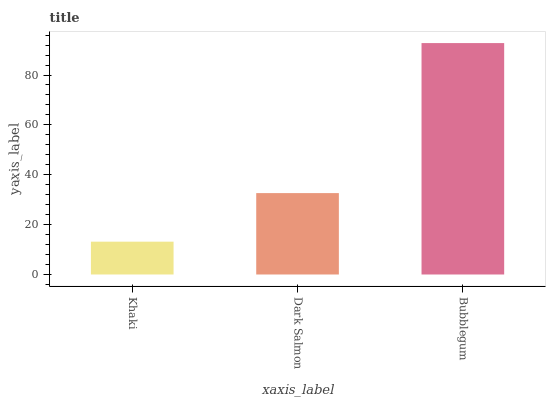Is Khaki the minimum?
Answer yes or no. Yes. Is Bubblegum the maximum?
Answer yes or no. Yes. Is Dark Salmon the minimum?
Answer yes or no. No. Is Dark Salmon the maximum?
Answer yes or no. No. Is Dark Salmon greater than Khaki?
Answer yes or no. Yes. Is Khaki less than Dark Salmon?
Answer yes or no. Yes. Is Khaki greater than Dark Salmon?
Answer yes or no. No. Is Dark Salmon less than Khaki?
Answer yes or no. No. Is Dark Salmon the high median?
Answer yes or no. Yes. Is Dark Salmon the low median?
Answer yes or no. Yes. Is Bubblegum the high median?
Answer yes or no. No. Is Bubblegum the low median?
Answer yes or no. No. 